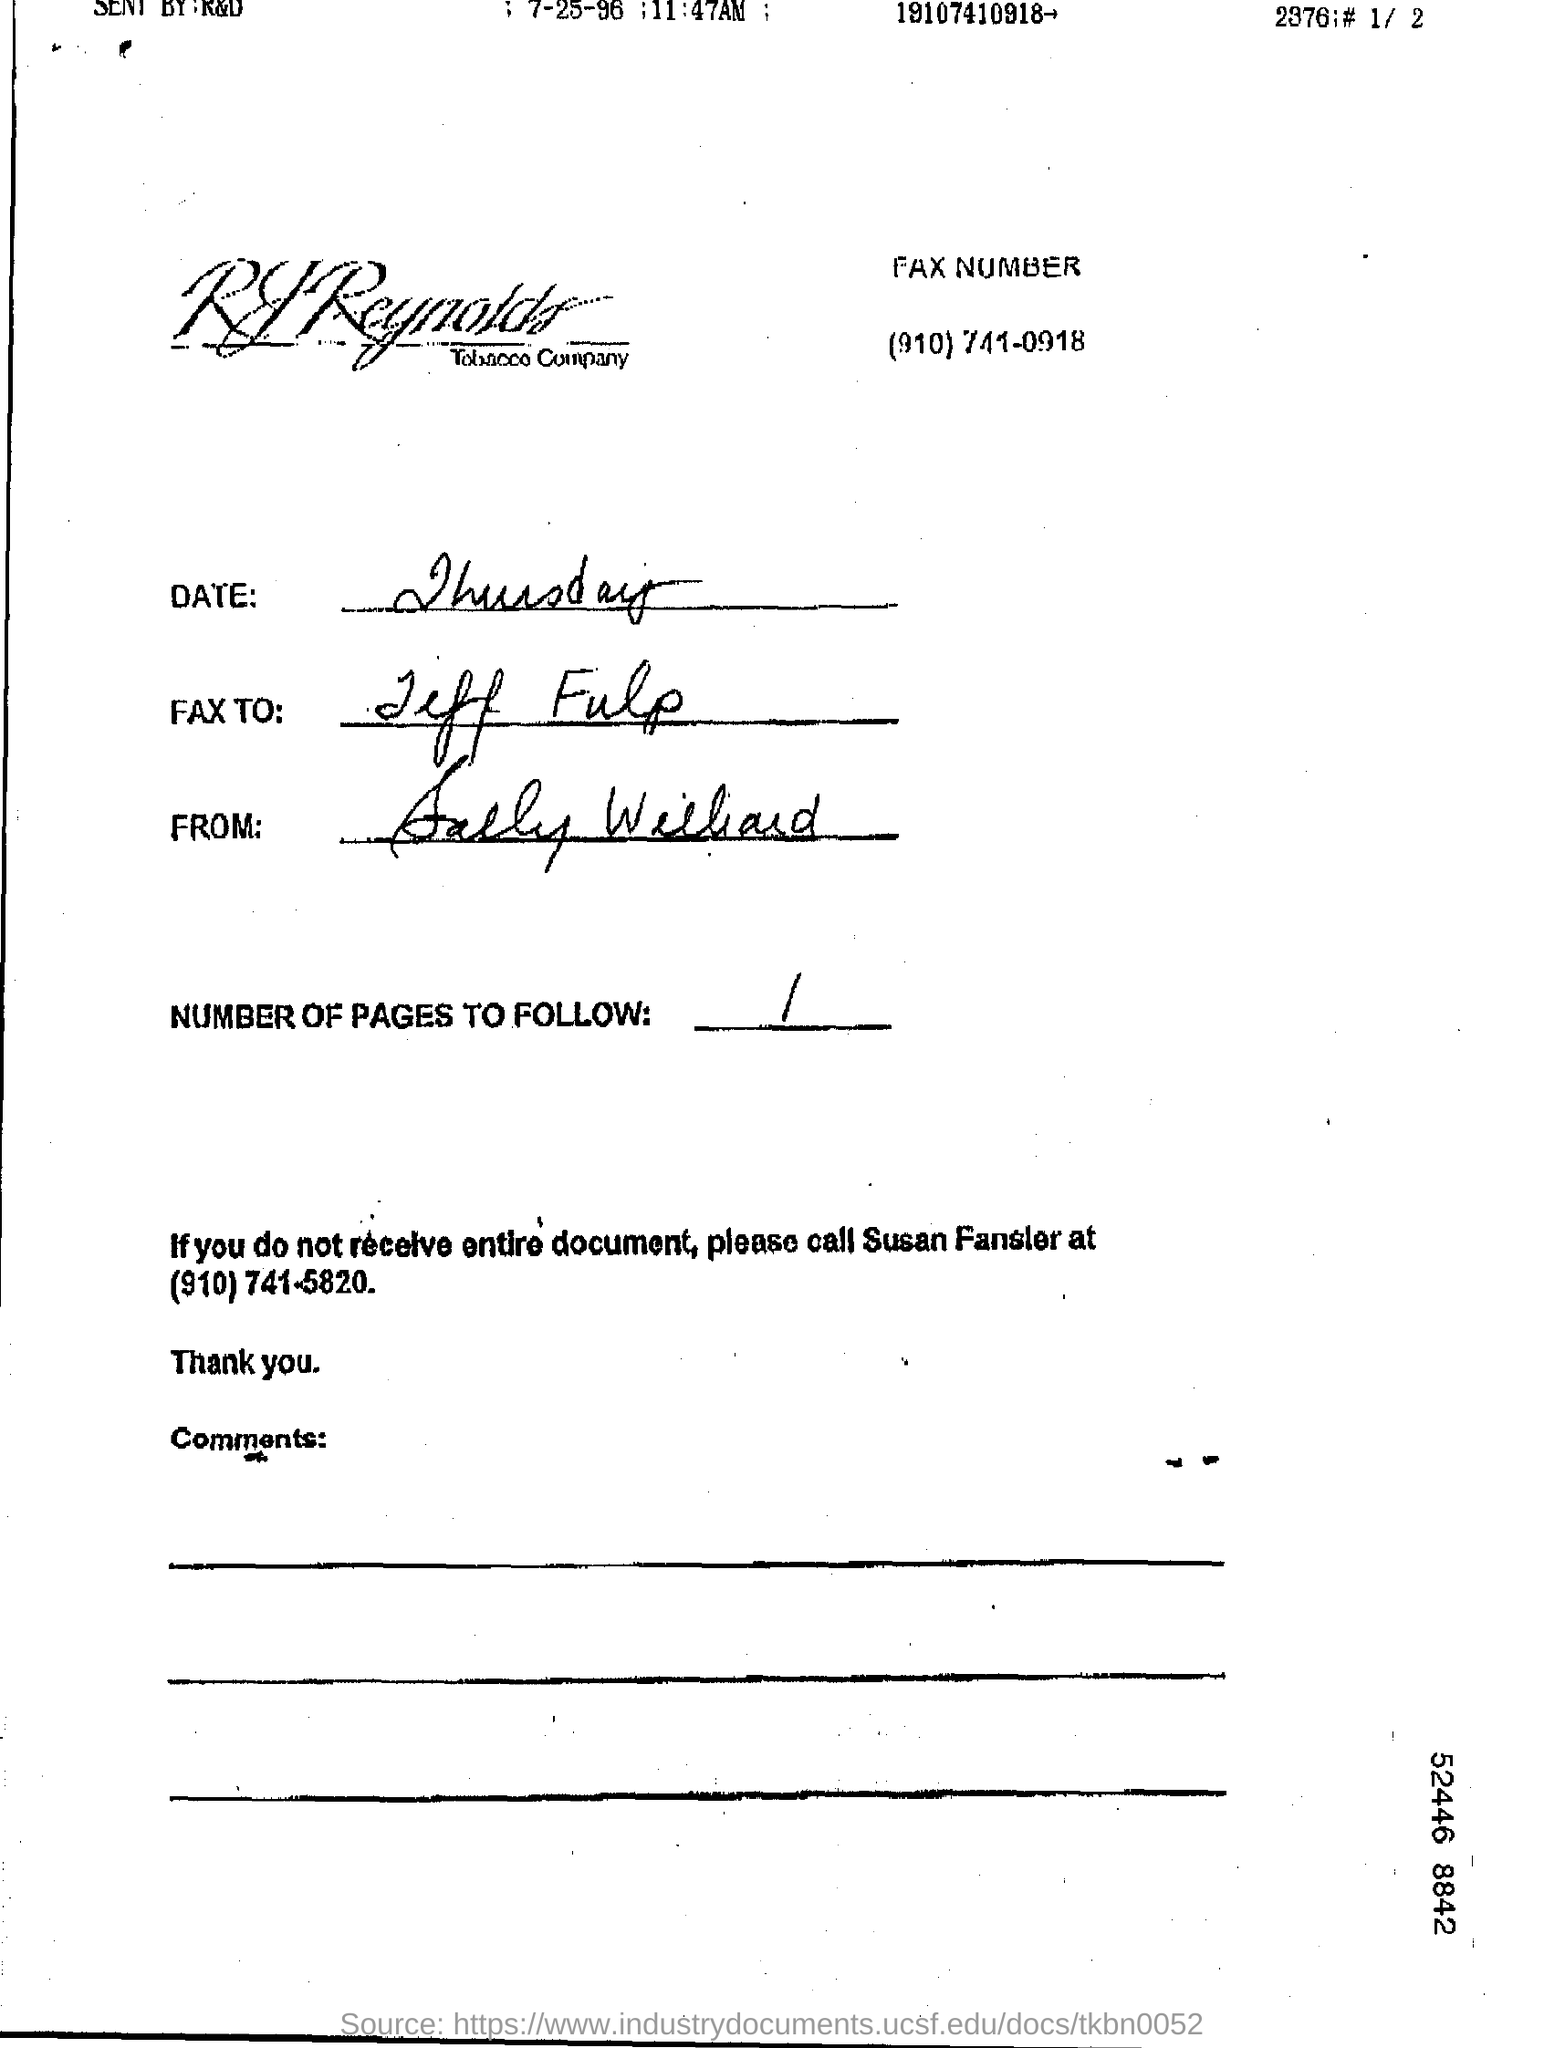Specify some key components in this picture. The date written in handwriting is 'Thursday.' This page can be accessed through 1.. 